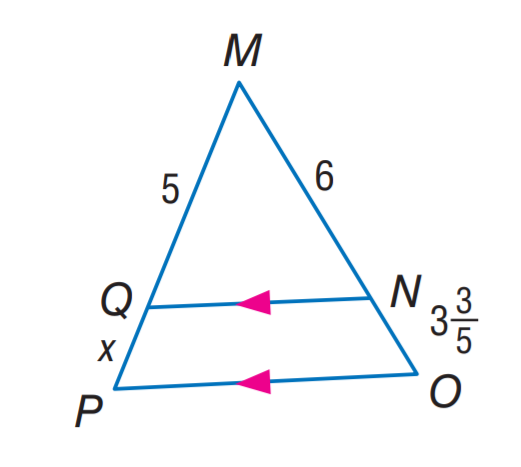Answer the mathemtical geometry problem and directly provide the correct option letter.
Question: Find M P.
Choices: A: 6 B: 8 C: 10 D: 12 B 